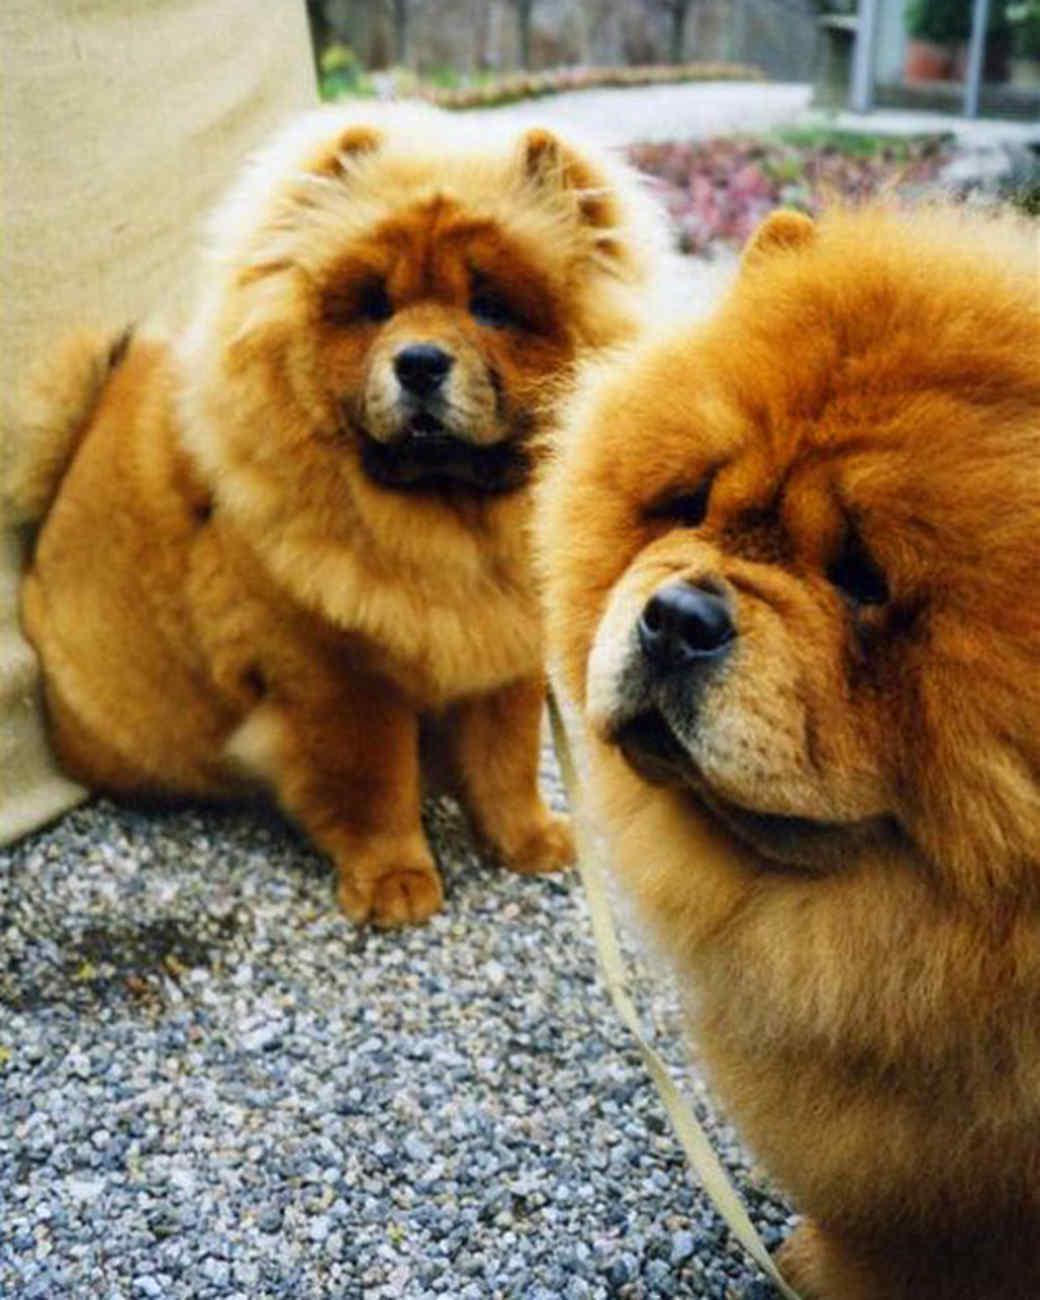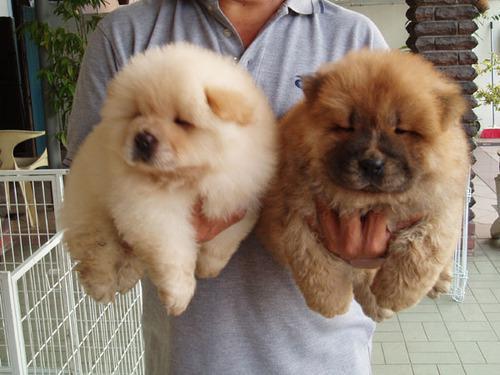The first image is the image on the left, the second image is the image on the right. Assess this claim about the two images: "There are exactly 3 dogs, and two of them are puppies.". Correct or not? Answer yes or no. No. The first image is the image on the left, the second image is the image on the right. Assess this claim about the two images: "There are exactly three dogs in total.". Correct or not? Answer yes or no. No. 